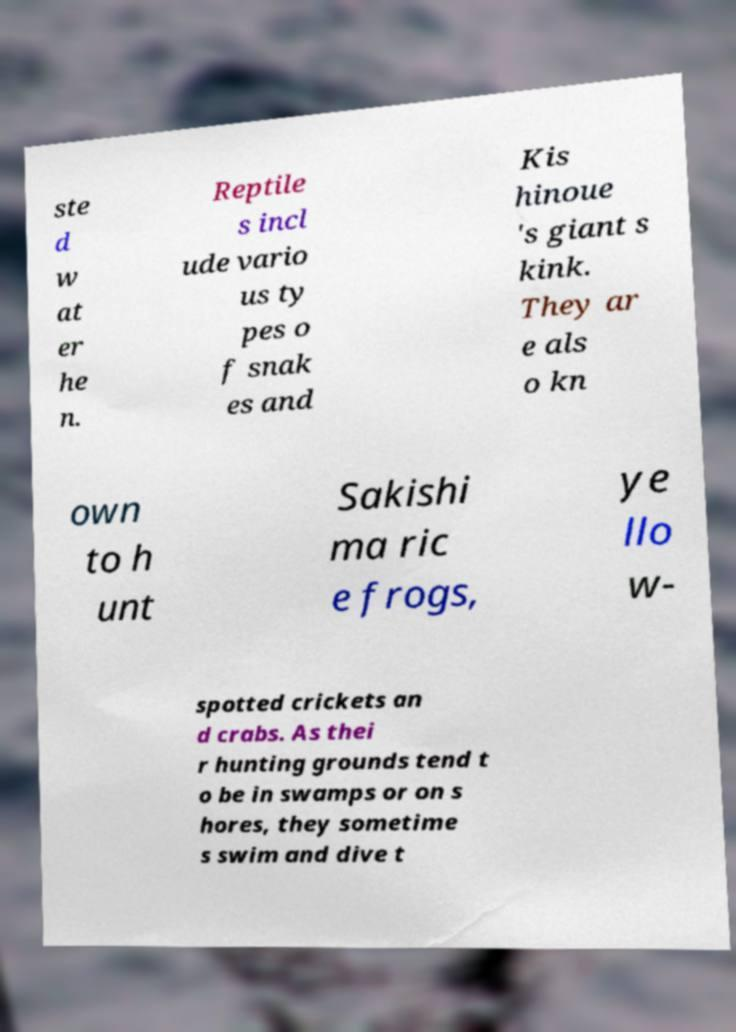There's text embedded in this image that I need extracted. Can you transcribe it verbatim? ste d w at er he n. Reptile s incl ude vario us ty pes o f snak es and Kis hinoue 's giant s kink. They ar e als o kn own to h unt Sakishi ma ric e frogs, ye llo w- spotted crickets an d crabs. As thei r hunting grounds tend t o be in swamps or on s hores, they sometime s swim and dive t 